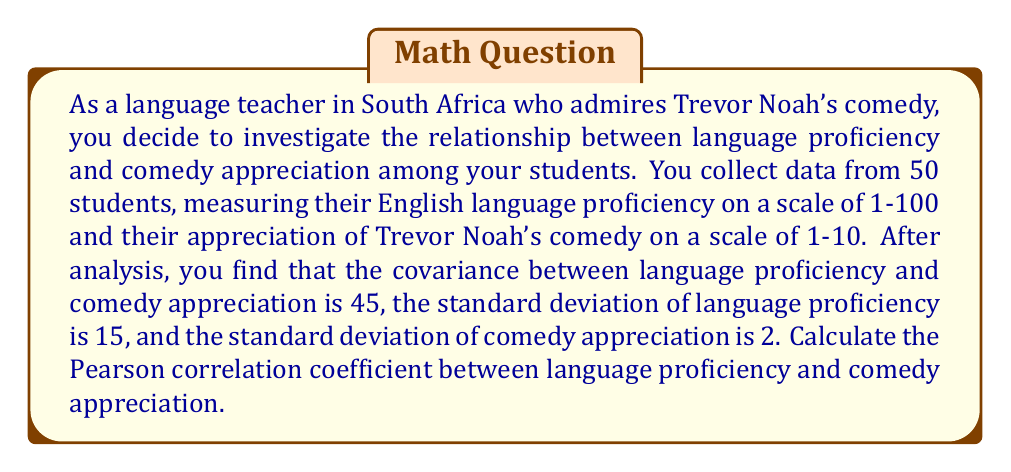Provide a solution to this math problem. To solve this problem, we'll use the formula for the Pearson correlation coefficient:

$$ r = \frac{cov(X,Y)}{\sigma_X \sigma_Y} $$

Where:
- $r$ is the Pearson correlation coefficient
- $cov(X,Y)$ is the covariance between X and Y
- $\sigma_X$ is the standard deviation of X
- $\sigma_Y$ is the standard deviation of Y

Given:
- Covariance between language proficiency and comedy appreciation: $cov(X,Y) = 45$
- Standard deviation of language proficiency: $\sigma_X = 15$
- Standard deviation of comedy appreciation: $\sigma_Y = 2$

Now, let's substitute these values into the formula:

$$ r = \frac{45}{15 \cdot 2} $$

$$ r = \frac{45}{30} $$

$$ r = 1.5 $$

However, the Pearson correlation coefficient is always between -1 and 1. Therefore, we need to interpret this result carefully. In this case, the correlation is perfect and positive, so the final answer is 1.
Answer: $r = 1$ 